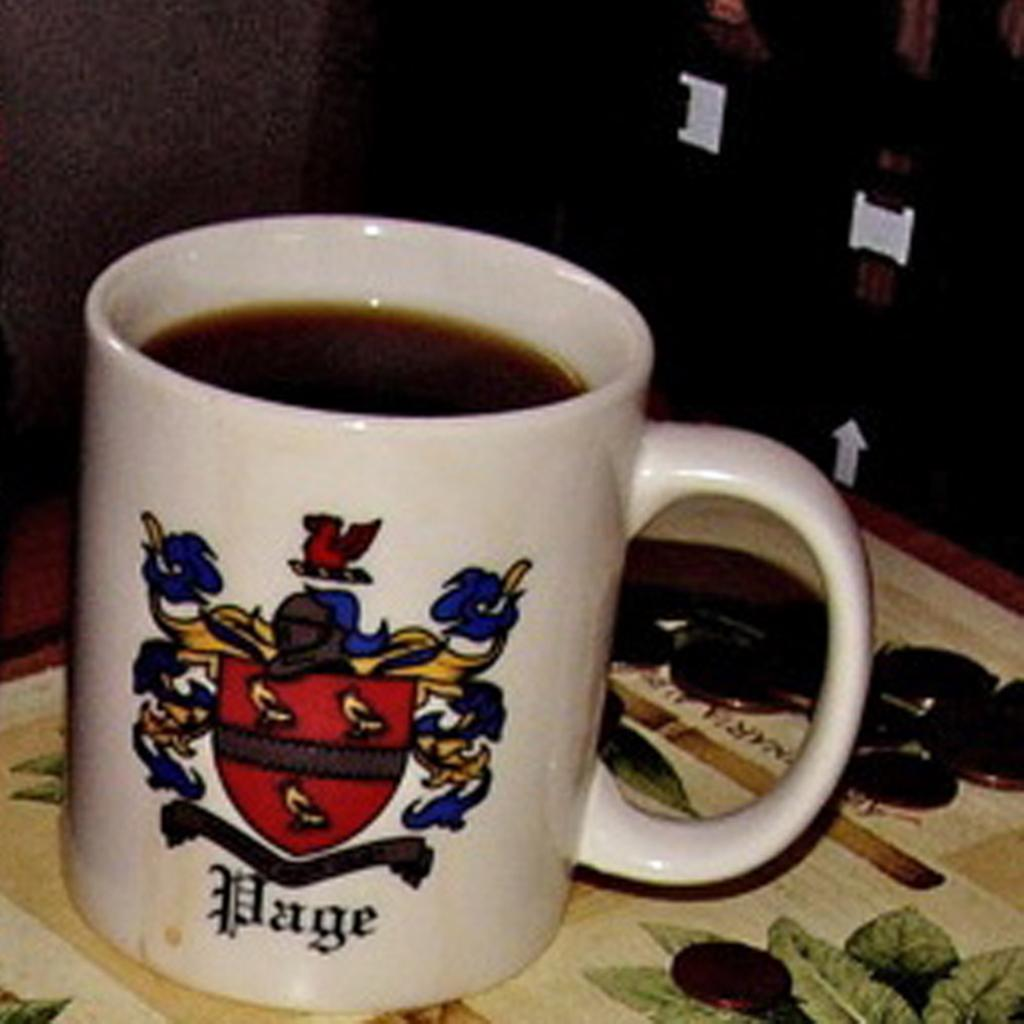<image>
Describe the image concisely. coffee mug with red, blue, and yellow coat of arms and word page at bottom and pile of coins to the side 